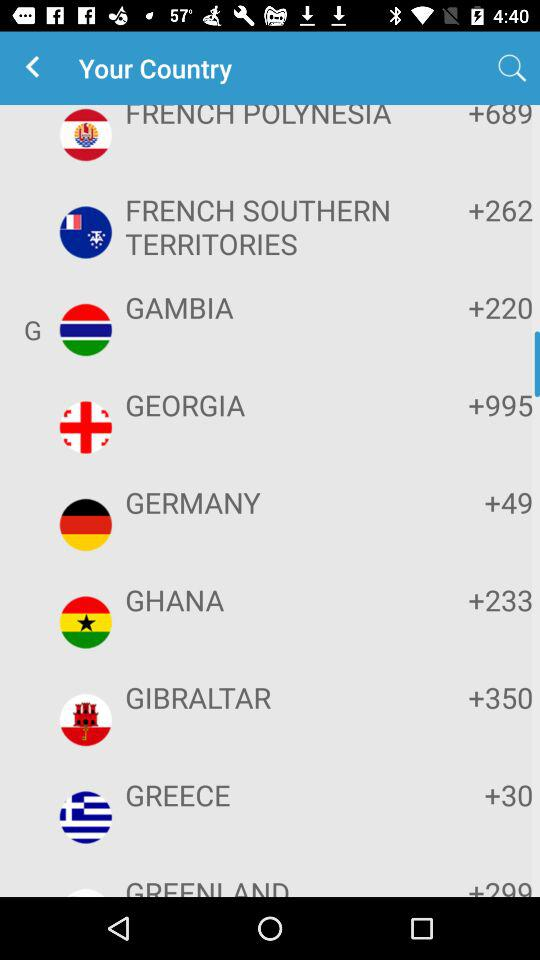What is the country code for Greece? The country code for Greece is +30. 